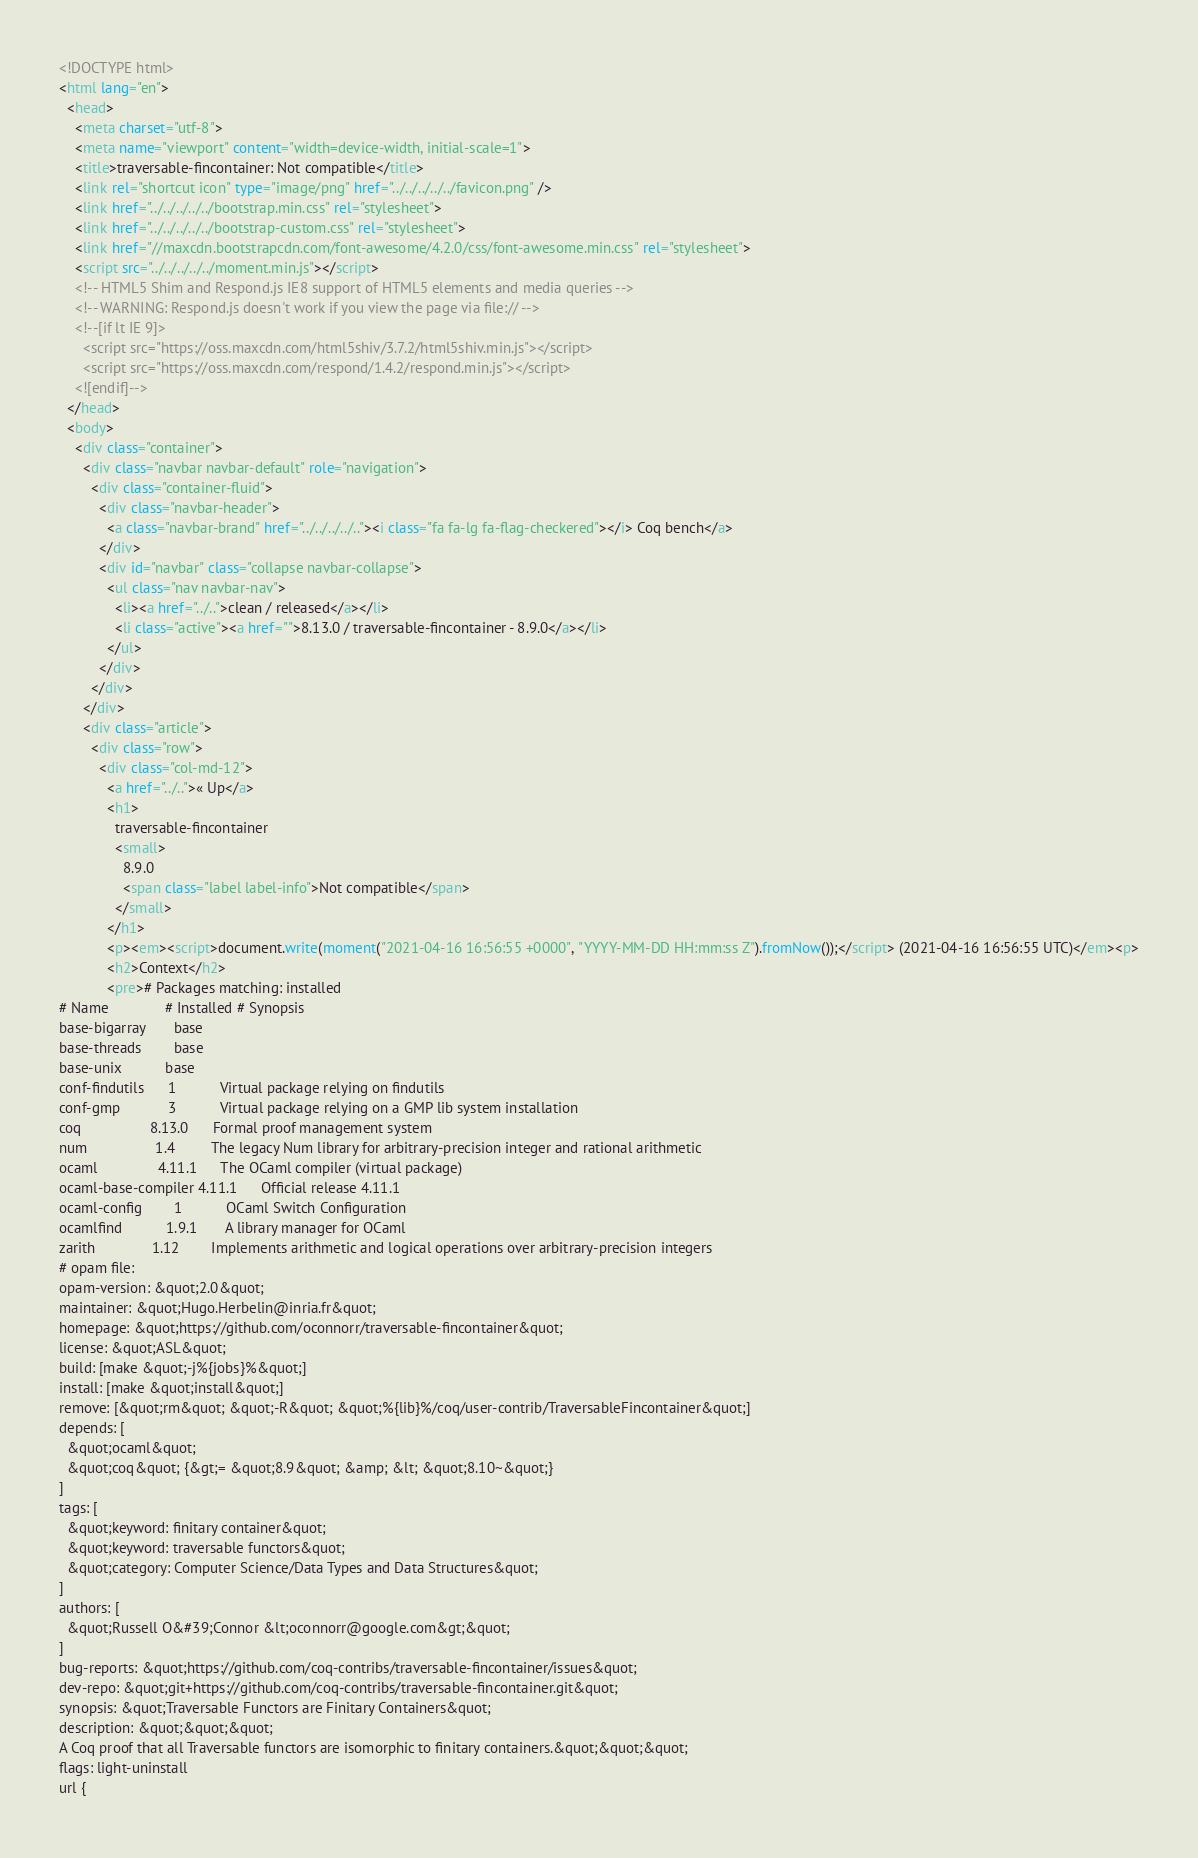<code> <loc_0><loc_0><loc_500><loc_500><_HTML_><!DOCTYPE html>
<html lang="en">
  <head>
    <meta charset="utf-8">
    <meta name="viewport" content="width=device-width, initial-scale=1">
    <title>traversable-fincontainer: Not compatible</title>
    <link rel="shortcut icon" type="image/png" href="../../../../../favicon.png" />
    <link href="../../../../../bootstrap.min.css" rel="stylesheet">
    <link href="../../../../../bootstrap-custom.css" rel="stylesheet">
    <link href="//maxcdn.bootstrapcdn.com/font-awesome/4.2.0/css/font-awesome.min.css" rel="stylesheet">
    <script src="../../../../../moment.min.js"></script>
    <!-- HTML5 Shim and Respond.js IE8 support of HTML5 elements and media queries -->
    <!-- WARNING: Respond.js doesn't work if you view the page via file:// -->
    <!--[if lt IE 9]>
      <script src="https://oss.maxcdn.com/html5shiv/3.7.2/html5shiv.min.js"></script>
      <script src="https://oss.maxcdn.com/respond/1.4.2/respond.min.js"></script>
    <![endif]-->
  </head>
  <body>
    <div class="container">
      <div class="navbar navbar-default" role="navigation">
        <div class="container-fluid">
          <div class="navbar-header">
            <a class="navbar-brand" href="../../../../.."><i class="fa fa-lg fa-flag-checkered"></i> Coq bench</a>
          </div>
          <div id="navbar" class="collapse navbar-collapse">
            <ul class="nav navbar-nav">
              <li><a href="../..">clean / released</a></li>
              <li class="active"><a href="">8.13.0 / traversable-fincontainer - 8.9.0</a></li>
            </ul>
          </div>
        </div>
      </div>
      <div class="article">
        <div class="row">
          <div class="col-md-12">
            <a href="../..">« Up</a>
            <h1>
              traversable-fincontainer
              <small>
                8.9.0
                <span class="label label-info">Not compatible</span>
              </small>
            </h1>
            <p><em><script>document.write(moment("2021-04-16 16:56:55 +0000", "YYYY-MM-DD HH:mm:ss Z").fromNow());</script> (2021-04-16 16:56:55 UTC)</em><p>
            <h2>Context</h2>
            <pre># Packages matching: installed
# Name              # Installed # Synopsis
base-bigarray       base
base-threads        base
base-unix           base
conf-findutils      1           Virtual package relying on findutils
conf-gmp            3           Virtual package relying on a GMP lib system installation
coq                 8.13.0      Formal proof management system
num                 1.4         The legacy Num library for arbitrary-precision integer and rational arithmetic
ocaml               4.11.1      The OCaml compiler (virtual package)
ocaml-base-compiler 4.11.1      Official release 4.11.1
ocaml-config        1           OCaml Switch Configuration
ocamlfind           1.9.1       A library manager for OCaml
zarith              1.12        Implements arithmetic and logical operations over arbitrary-precision integers
# opam file:
opam-version: &quot;2.0&quot;
maintainer: &quot;Hugo.Herbelin@inria.fr&quot;
homepage: &quot;https://github.com/oconnorr/traversable-fincontainer&quot;
license: &quot;ASL&quot;
build: [make &quot;-j%{jobs}%&quot;]
install: [make &quot;install&quot;]
remove: [&quot;rm&quot; &quot;-R&quot; &quot;%{lib}%/coq/user-contrib/TraversableFincontainer&quot;]
depends: [
  &quot;ocaml&quot;
  &quot;coq&quot; {&gt;= &quot;8.9&quot; &amp; &lt; &quot;8.10~&quot;}
]
tags: [
  &quot;keyword: finitary container&quot;
  &quot;keyword: traversable functors&quot;
  &quot;category: Computer Science/Data Types and Data Structures&quot;
]
authors: [
  &quot;Russell O&#39;Connor &lt;oconnorr@google.com&gt;&quot;
]
bug-reports: &quot;https://github.com/coq-contribs/traversable-fincontainer/issues&quot;
dev-repo: &quot;git+https://github.com/coq-contribs/traversable-fincontainer.git&quot;
synopsis: &quot;Traversable Functors are Finitary Containers&quot;
description: &quot;&quot;&quot;
A Coq proof that all Traversable functors are isomorphic to finitary containers.&quot;&quot;&quot;
flags: light-uninstall
url {</code> 